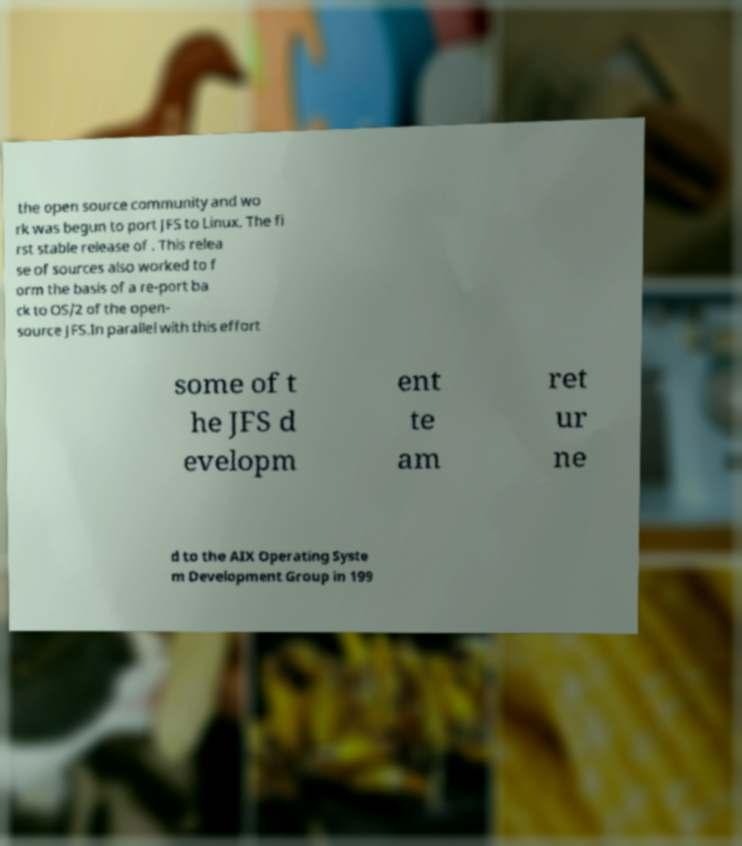Could you assist in decoding the text presented in this image and type it out clearly? the open source community and wo rk was begun to port JFS to Linux. The fi rst stable release of . This relea se of sources also worked to f orm the basis of a re-port ba ck to OS/2 of the open- source JFS.In parallel with this effort some of t he JFS d evelopm ent te am ret ur ne d to the AIX Operating Syste m Development Group in 199 